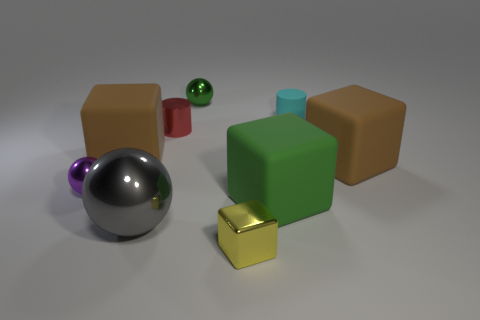How many other things are the same shape as the gray thing? There are two objects that share the same shape as the gray sphere, which are the purple and the green spheres. 